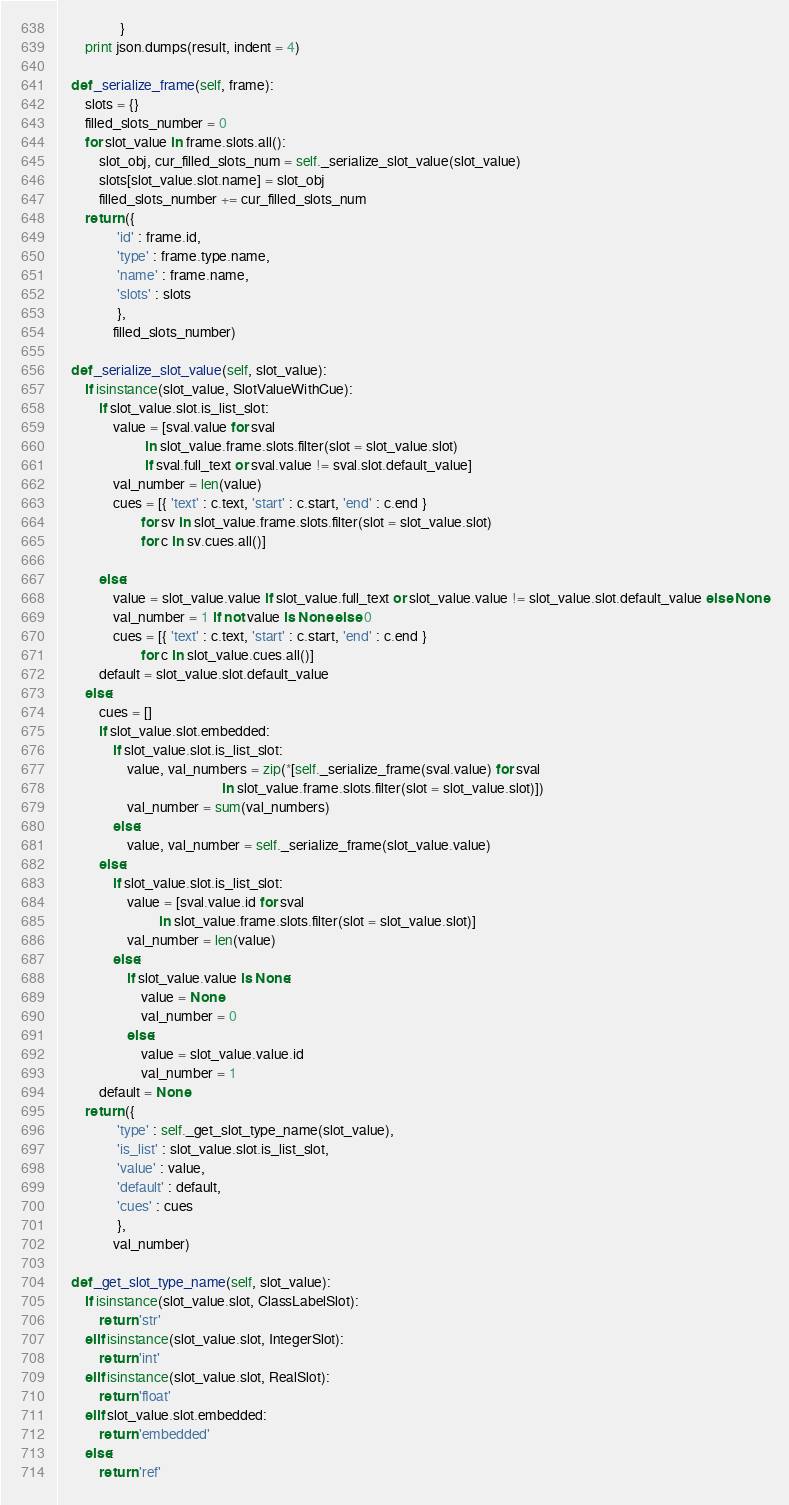Convert code to text. <code><loc_0><loc_0><loc_500><loc_500><_Python_>                  }
        print json.dumps(result, indent = 4)

    def _serialize_frame(self, frame):
        slots = {}
        filled_slots_number = 0
        for slot_value in frame.slots.all():
            slot_obj, cur_filled_slots_num = self._serialize_slot_value(slot_value)
            slots[slot_value.slot.name] = slot_obj
            filled_slots_number += cur_filled_slots_num
        return ({
                 'id' : frame.id,
                 'type' : frame.type.name,
                 'name' : frame.name,
                 'slots' : slots
                 },
                filled_slots_number)

    def _serialize_slot_value(self, slot_value):
        if isinstance(slot_value, SlotValueWithCue):
            if slot_value.slot.is_list_slot:
                value = [sval.value for sval
                         in slot_value.frame.slots.filter(slot = slot_value.slot)
                         if sval.full_text or sval.value != sval.slot.default_value]
                val_number = len(value)
                cues = [{ 'text' : c.text, 'start' : c.start, 'end' : c.end }
                        for sv in slot_value.frame.slots.filter(slot = slot_value.slot)
                        for c in sv.cues.all()]
                
            else:
                value = slot_value.value if slot_value.full_text or slot_value.value != slot_value.slot.default_value else None
                val_number = 1 if not value is None else 0
                cues = [{ 'text' : c.text, 'start' : c.start, 'end' : c.end }
                        for c in slot_value.cues.all()]
            default = slot_value.slot.default_value
        else:
            cues = []
            if slot_value.slot.embedded:
                if slot_value.slot.is_list_slot: 
                    value, val_numbers = zip(*[self._serialize_frame(sval.value) for sval
                                               in slot_value.frame.slots.filter(slot = slot_value.slot)])
                    val_number = sum(val_numbers)
                else:
                    value, val_number = self._serialize_frame(slot_value.value)
            else:
                if slot_value.slot.is_list_slot: 
                    value = [sval.value.id for sval
                             in slot_value.frame.slots.filter(slot = slot_value.slot)]
                    val_number = len(value)
                else:
                    if slot_value.value is None:
                        value = None
                        val_number = 0
                    else:
                        value = slot_value.value.id
                        val_number = 1
            default = None
        return ({
                 'type' : self._get_slot_type_name(slot_value),
                 'is_list' : slot_value.slot.is_list_slot,
                 'value' : value,
                 'default' : default,
                 'cues' : cues
                 },
                val_number)

    def _get_slot_type_name(self, slot_value):
        if isinstance(slot_value.slot, ClassLabelSlot):
            return 'str'
        elif isinstance(slot_value.slot, IntegerSlot):
            return 'int'
        elif isinstance(slot_value.slot, RealSlot):
            return 'float'
        elif slot_value.slot.embedded:
            return 'embedded'
        else:
            return 'ref'

</code> 